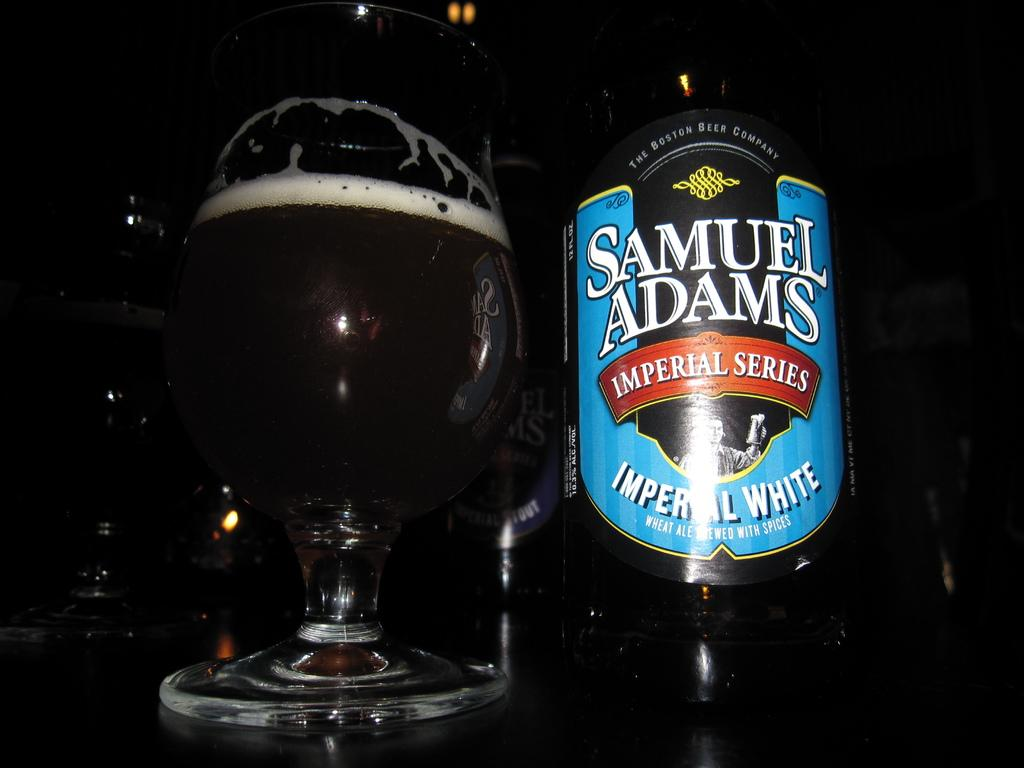Provide a one-sentence caption for the provided image. A bottle of Samuel Adams beer, specifically the Imperial White variety. 